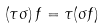Convert formula to latex. <formula><loc_0><loc_0><loc_500><loc_500>\left ( \tau \sigma \right ) f = \tau ( \sigma f )</formula> 